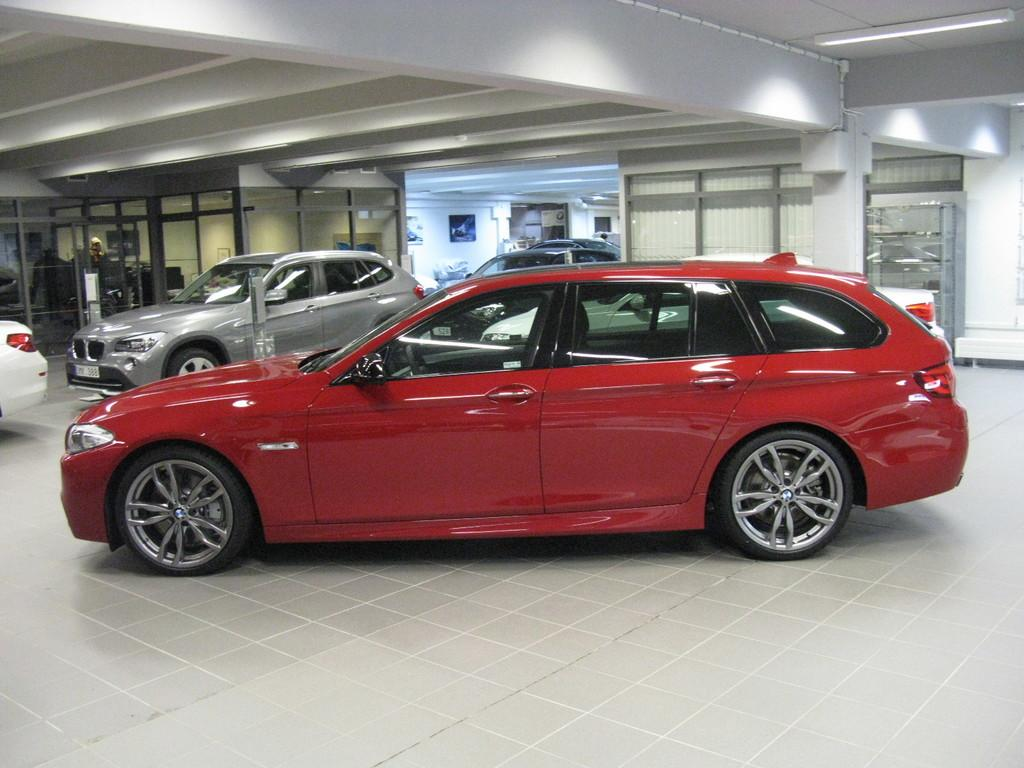What type of objects are present in the image? There are colorful vehicles in the image. Where are the vehicles located? The vehicles are inside a building. What can be seen on the walls in the background of the image? There are boards on the wall in the background of the image. Can you tell me how many carriages are running in the image? There are no carriages present in the image, and the vehicles are not running; they are inside a building. What type of oven can be seen in the image? There is no oven present in the image. 